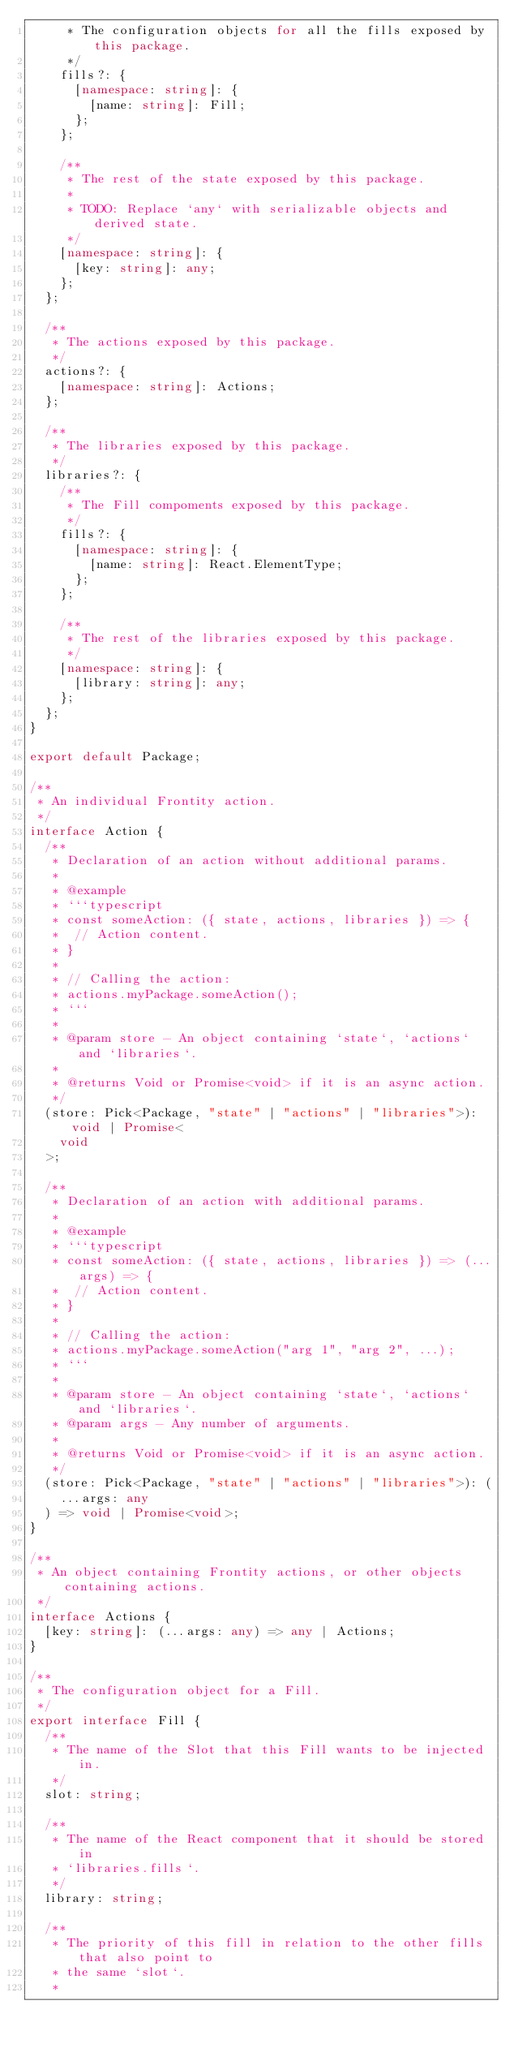<code> <loc_0><loc_0><loc_500><loc_500><_TypeScript_>     * The configuration objects for all the fills exposed by this package.
     */
    fills?: {
      [namespace: string]: {
        [name: string]: Fill;
      };
    };

    /**
     * The rest of the state exposed by this package.
     *
     * TODO: Replace `any` with serializable objects and derived state.
     */
    [namespace: string]: {
      [key: string]: any;
    };
  };

  /**
   * The actions exposed by this package.
   */
  actions?: {
    [namespace: string]: Actions;
  };

  /**
   * The libraries exposed by this package.
   */
  libraries?: {
    /**
     * The Fill compoments exposed by this package.
     */
    fills?: {
      [namespace: string]: {
        [name: string]: React.ElementType;
      };
    };

    /**
     * The rest of the libraries exposed by this package.
     */
    [namespace: string]: {
      [library: string]: any;
    };
  };
}

export default Package;

/**
 * An individual Frontity action.
 */
interface Action {
  /**
   * Declaration of an action without additional params.
   *
   * @example
   * ```typescript
   * const someAction: ({ state, actions, libraries }) => {
   *  // Action content.
   * }
   *
   * // Calling the action:
   * actions.myPackage.someAction();
   * ```
   *
   * @param store - An object containing `state`, `actions` and `libraries`.
   *
   * @returns Void or Promise<void> if it is an async action.
   */
  (store: Pick<Package, "state" | "actions" | "libraries">): void | Promise<
    void
  >;

  /**
   * Declaration of an action with additional params.
   *
   * @example
   * ```typescript
   * const someAction: ({ state, actions, libraries }) => (...args) => {
   *  // Action content.
   * }
   *
   * // Calling the action:
   * actions.myPackage.someAction("arg 1", "arg 2", ...);
   * ```
   *
   * @param store - An object containing `state`, `actions` and `libraries`.
   * @param args - Any number of arguments.
   *
   * @returns Void or Promise<void> if it is an async action.
   */
  (store: Pick<Package, "state" | "actions" | "libraries">): (
    ...args: any
  ) => void | Promise<void>;
}

/**
 * An object containing Frontity actions, or other objects containing actions.
 */
interface Actions {
  [key: string]: (...args: any) => any | Actions;
}

/**
 * The configuration object for a Fill.
 */
export interface Fill {
  /**
   * The name of the Slot that this Fill wants to be injected in.
   */
  slot: string;

  /**
   * The name of the React component that it should be stored in
   * `libraries.fills`.
   */
  library: string;

  /**
   * The priority of this fill in relation to the other fills that also point to
   * the same `slot`.
   *</code> 